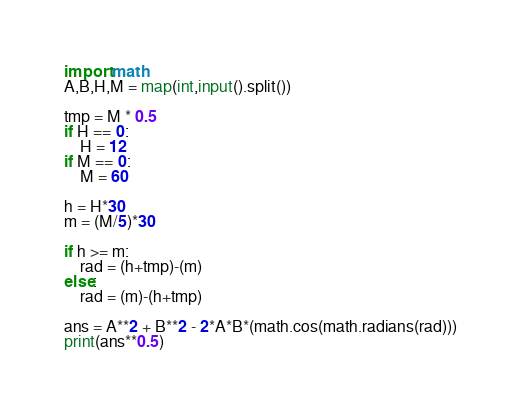Convert code to text. <code><loc_0><loc_0><loc_500><loc_500><_Python_>import math
A,B,H,M = map(int,input().split())

tmp = M * 0.5
if H == 0:
    H = 12
if M == 0:
    M = 60

h = H*30
m = (M/5)*30

if h >= m:
    rad = (h+tmp)-(m)
else:
    rad = (m)-(h+tmp)

ans = A**2 + B**2 - 2*A*B*(math.cos(math.radians(rad)))
print(ans**0.5)
</code> 